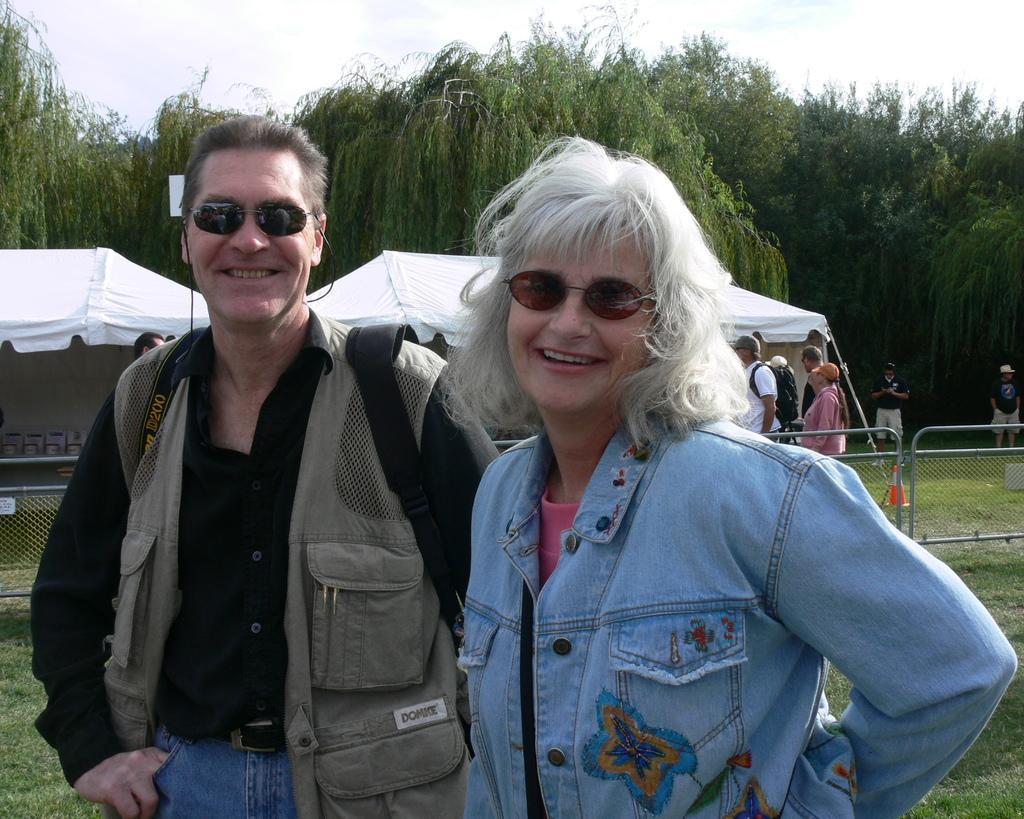In one or two sentences, can you explain what this image depicts? In this picture there are two people standing and smiling and wore goggles and we can see grass, behind these two people we can see fence, people, traffic cone and tents. In the background of the image we can see trees and sky. 